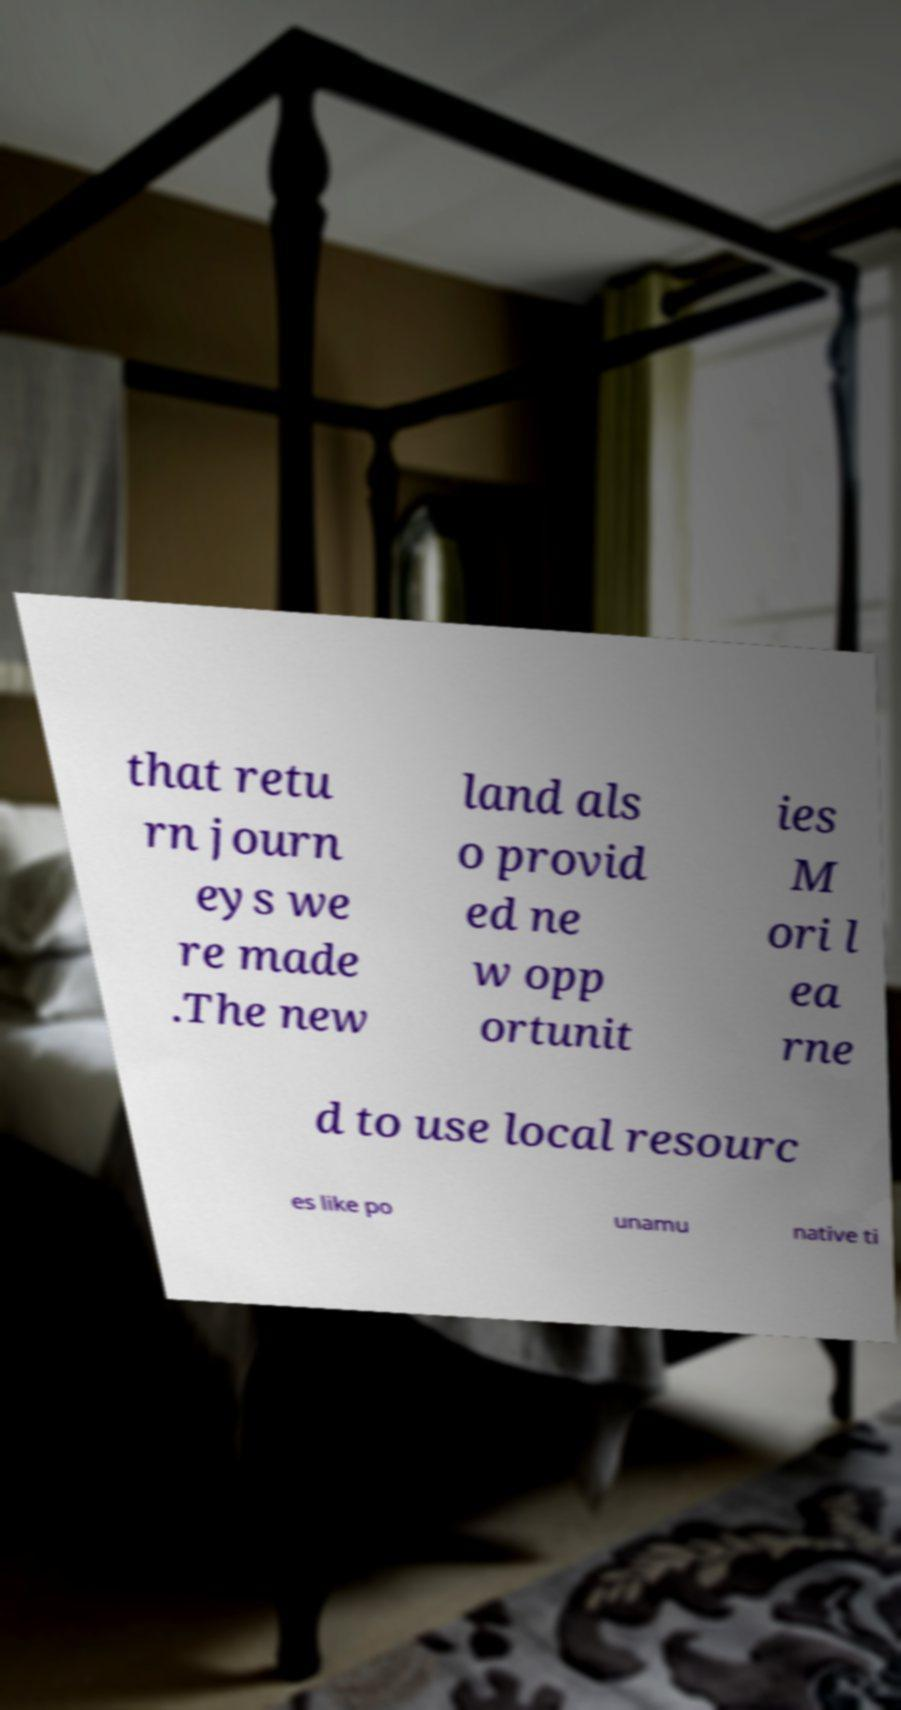Please read and relay the text visible in this image. What does it say? that retu rn journ eys we re made .The new land als o provid ed ne w opp ortunit ies M ori l ea rne d to use local resourc es like po unamu native ti 